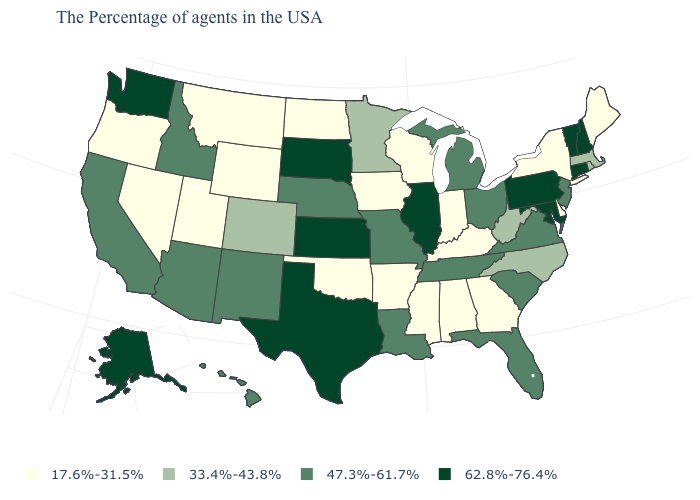What is the lowest value in the USA?
Keep it brief. 17.6%-31.5%. What is the value of Massachusetts?
Short answer required. 33.4%-43.8%. What is the value of New Mexico?
Concise answer only. 47.3%-61.7%. How many symbols are there in the legend?
Give a very brief answer. 4. What is the value of Louisiana?
Give a very brief answer. 47.3%-61.7%. Name the states that have a value in the range 17.6%-31.5%?
Concise answer only. Maine, New York, Delaware, Georgia, Kentucky, Indiana, Alabama, Wisconsin, Mississippi, Arkansas, Iowa, Oklahoma, North Dakota, Wyoming, Utah, Montana, Nevada, Oregon. Does Utah have the same value as Georgia?
Write a very short answer. Yes. Does the map have missing data?
Give a very brief answer. No. Does the first symbol in the legend represent the smallest category?
Be succinct. Yes. Which states have the highest value in the USA?
Be succinct. New Hampshire, Vermont, Connecticut, Maryland, Pennsylvania, Illinois, Kansas, Texas, South Dakota, Washington, Alaska. Which states have the highest value in the USA?
Quick response, please. New Hampshire, Vermont, Connecticut, Maryland, Pennsylvania, Illinois, Kansas, Texas, South Dakota, Washington, Alaska. Does the map have missing data?
Keep it brief. No. Which states hav the highest value in the South?
Short answer required. Maryland, Texas. Name the states that have a value in the range 47.3%-61.7%?
Write a very short answer. New Jersey, Virginia, South Carolina, Ohio, Florida, Michigan, Tennessee, Louisiana, Missouri, Nebraska, New Mexico, Arizona, Idaho, California, Hawaii. Does the first symbol in the legend represent the smallest category?
Short answer required. Yes. 